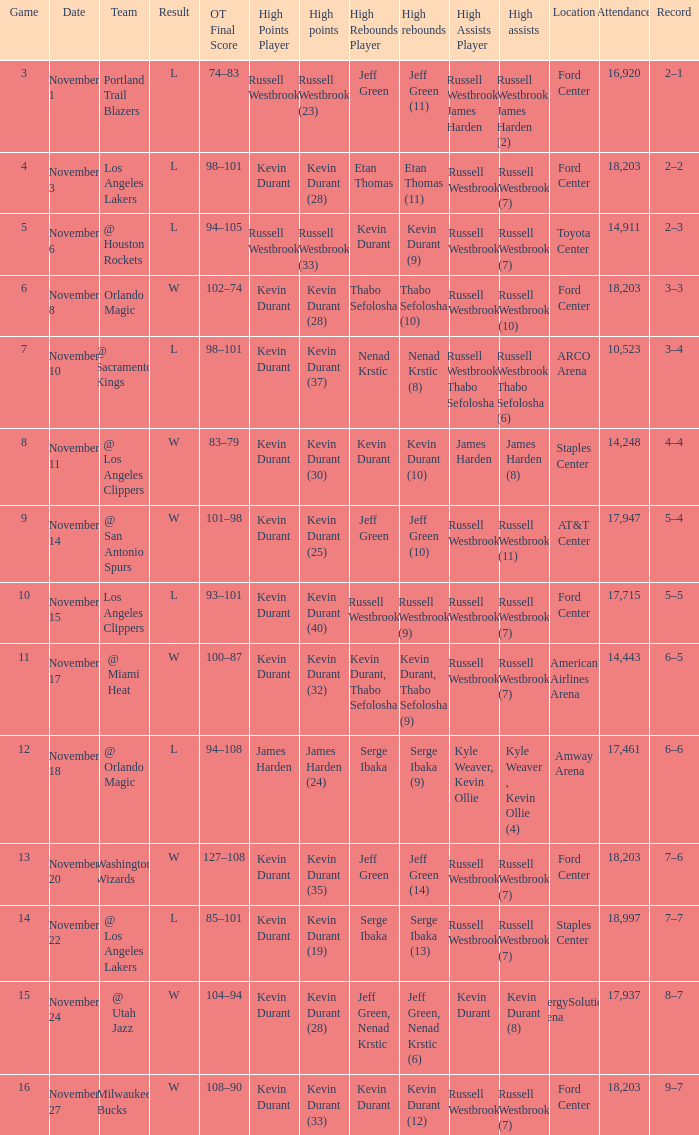What was the record in the game in which Jeff Green (14) did the most high rebounds? 7–6. 